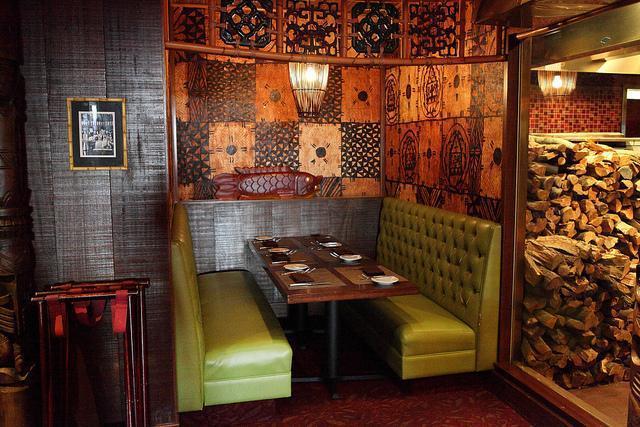How many couches are in the picture?
Give a very brief answer. 2. 